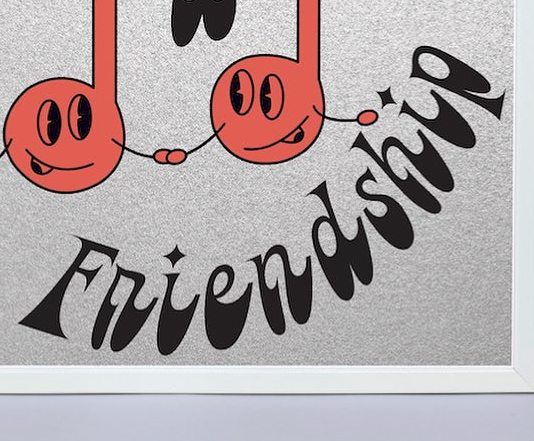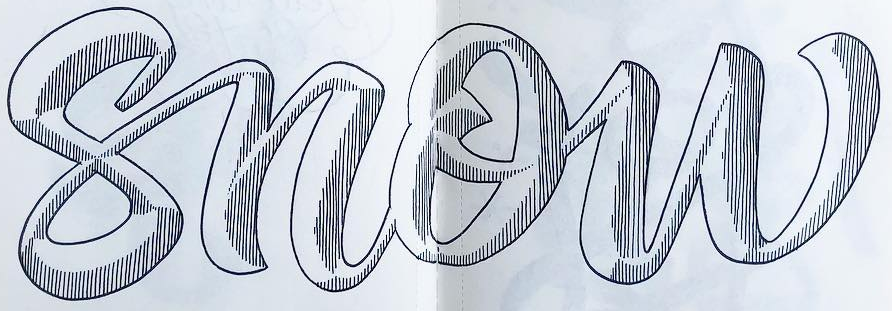What text is displayed in these images sequentially, separated by a semicolon? Friendship; snow 